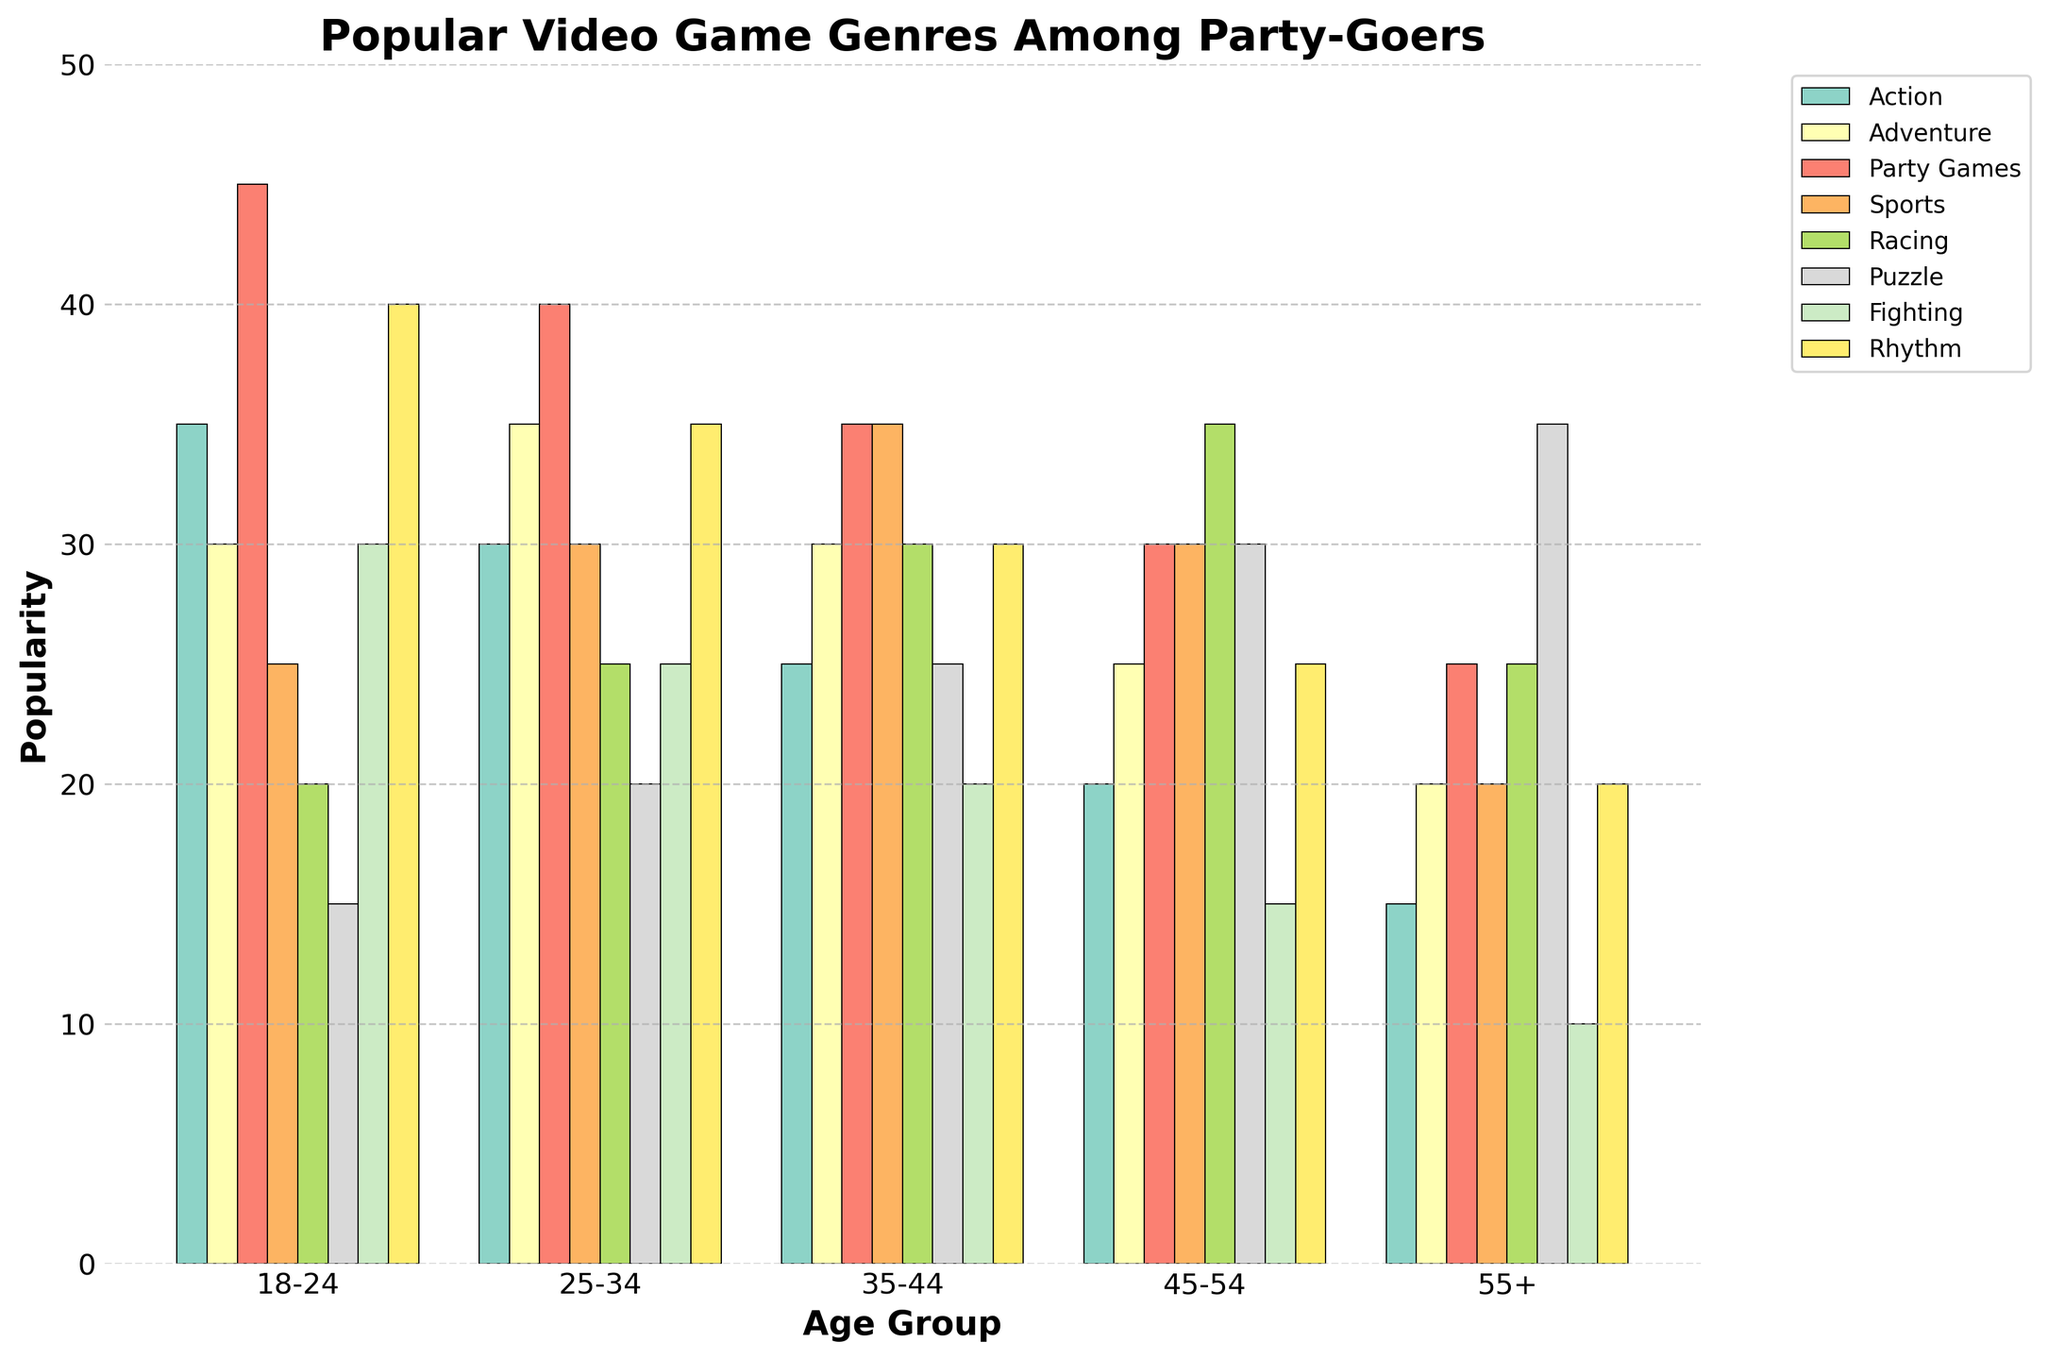What is the most popular video game genre among the 18-24 age group? Look at the bar heights for the 18-24 age group and identify which bar is the tallest. The tallest bar corresponds to Party Games with a height of 45.
Answer: Party Games How much more popular are Action games among the 18-24 age group as compared to the 55+ age group? Find the Action bar heights for both the 18-24 and 55+ age groups and calculate the difference. For the 18-24 age group, the height is 35, and for the 55+ age group, it is 15. Subtract 15 from 35.
Answer: 20 Which age group shows the least interest in Fighting games? Compare the bar heights for Fighting games across all age groups. The 55+ age group has the shortest bar with a height of 10.
Answer: 55+ What is the average popularity of Rhythm games across all age groups? Sum the bar heights for Rhythm games across all age groups and divide by the number of age groups. The heights are 40, 35, 30, 25, and 20; sum is 150, with 5 age groups, so the average is 150/5.
Answer: 30 Which genre shows a consistent decrease in popularity as the age increases? Observe the trend in bar heights for each genre from the youngest to the oldest age group. Action shows a consistent decline: 35, 30, 25, 20, 15.
Answer: Action In which age group do Puzzle games reach their highest popularity? Look for the tallest Puzzle bar among all age groups. The 55+ age group has the highest Puzzle bar with a height of 35.
Answer: 55+ Which two age groups have the same popularity for Racing games? Compare the bar heights for Racing games across all age groups and find the age groups with equal bar heights. Both the 35-44 and 45-54 age groups have Racing game heights of 30.
Answer: 35-44 and 45-54 What is the difference in popularity between Sports games and Rhythm games for the 25-34 age group? Identify the bar heights for Sports and Rhythm games for the 25-34 age group and find the difference. Sports have a height of 30, while Rhythm has a height of 35. Subtract 30 from 35.
Answer: 5 Among the 35-44 age group, which genre has a popularity exactly midway between Action and Party Games? For the 35-44 age group, Action is 25 and Party Games is 35. The midpoint is (25 + 35) / 2 = 30. Adventure has a popularity of 30, which is midway.
Answer: Adventure 